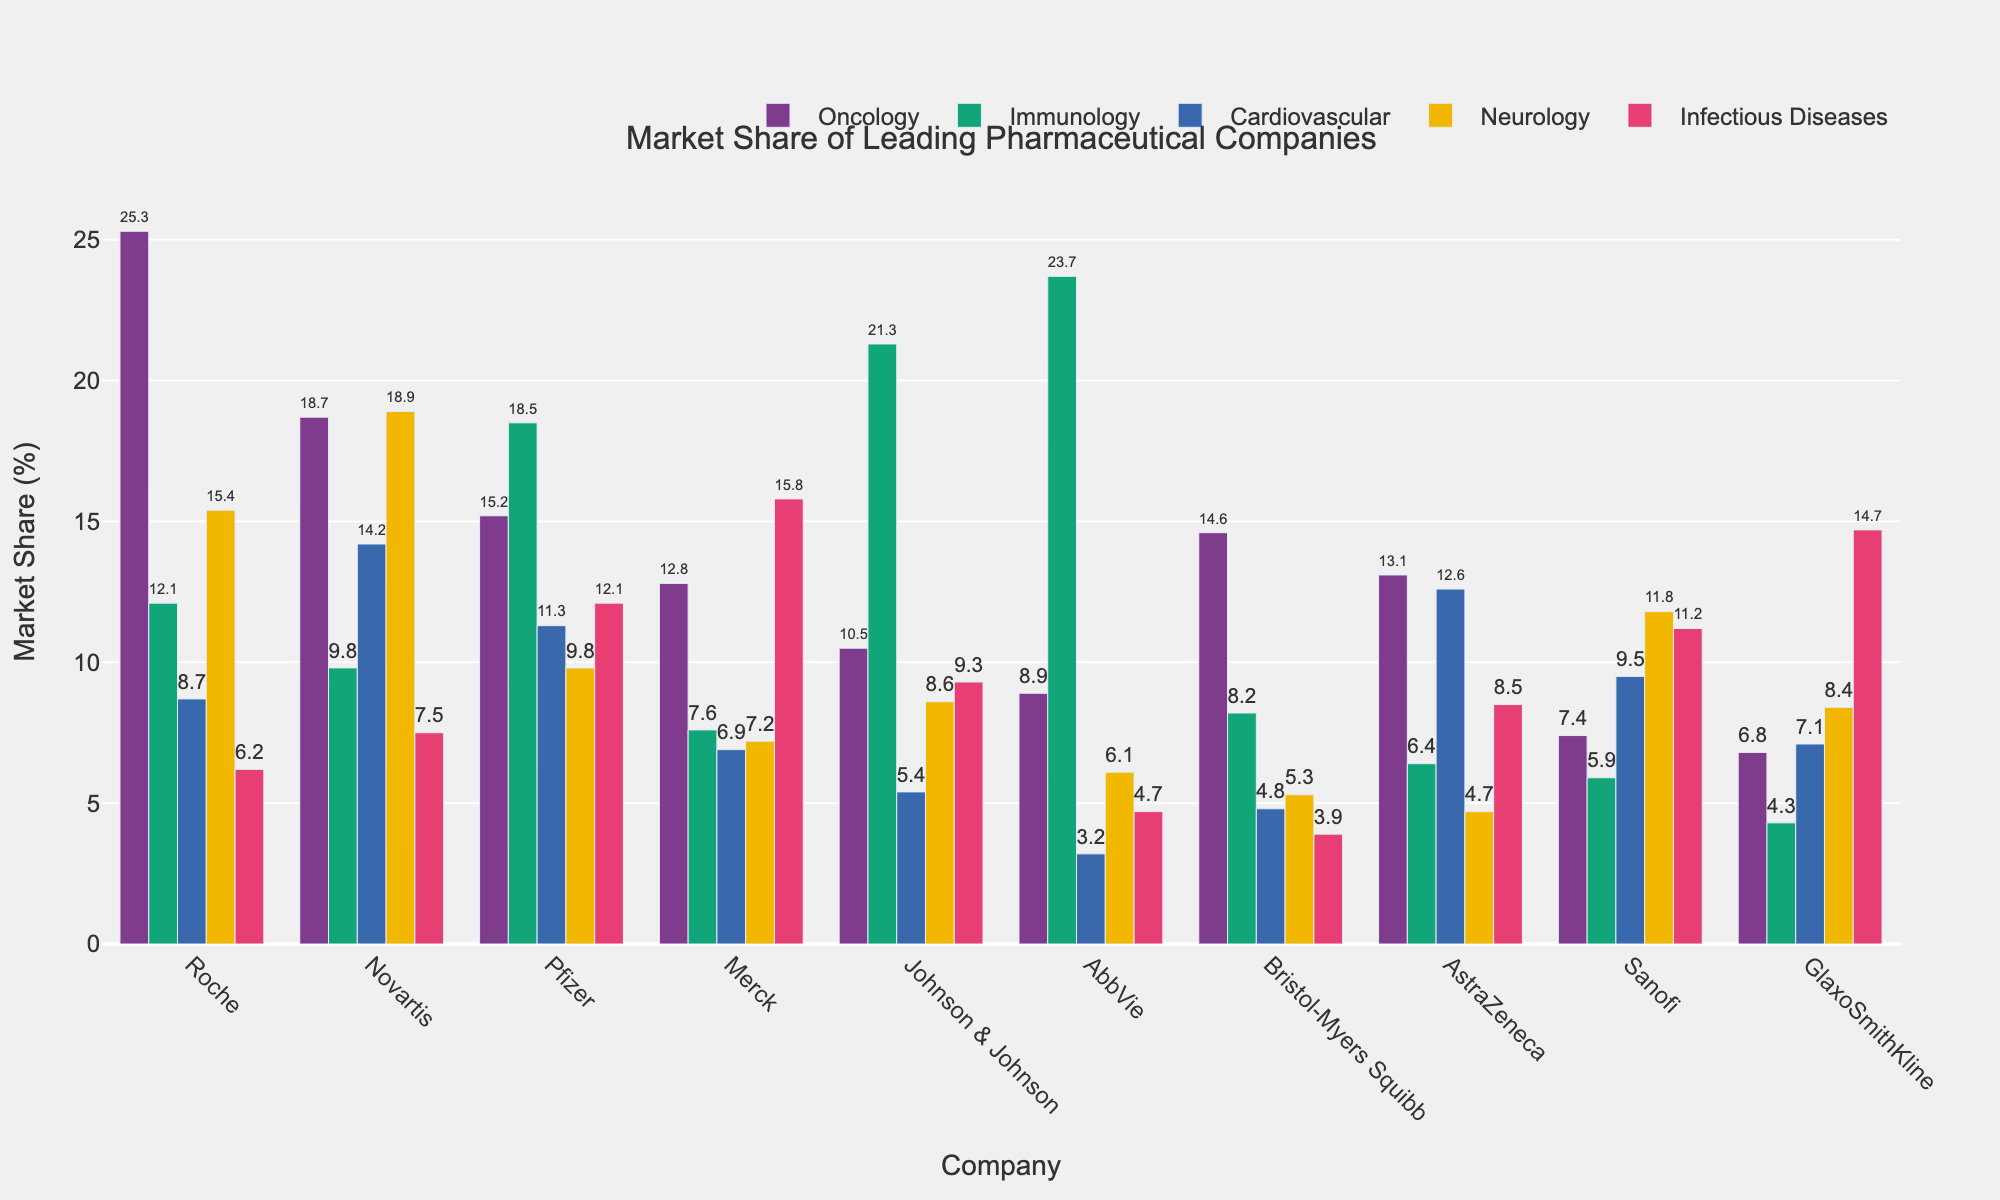What is the company with the highest market share in Immunology? Look at the bar heights for Immunology. The highest bar represents AbbVie, which has the greatest market share in this segment.
Answer: AbbVie Which company has the lowest market share in Oncology? Observe the heights of the bars for Oncology. The shortest bar indicates Sanofi has the lowest market share in this segment.
Answer: Sanofi Which therapeutic segment has the most balanced distribution of market shares among the companies? This involves comparing the differences in bar heights across all therapeutic segments. The Immunology segment shows relatively balanced heights without extreme values across the companies.
Answer: Immunology How does Roche's market share in Infectious Diseases compare to Pfizer's? Compare the bar heights for Roche and Pfizer in the Infectious Diseases segment. Roche's share is lower than Pfizer's, as indicated by the shorter bar.
Answer: Lower What is the total market share of Novartis across all therapeutic segments? Add Novartis’s market share values from all segments: 18.7 (Oncology) + 9.8 (Immunology) + 14.2 (Cardiovascular) + 18.9 (Neurology) + 7.5 (Infectious Diseases). This equals 69.1%.
Answer: 69.1% What is the average market share of Johnson & Johnson across all segments? Calculate the average by summing Johnson & Johnson’s values in all segments: 10.5 (Oncology) + 21.3 (Immunology) + 5.4 (Cardiovascular) + 8.6 (Neurology) + 9.3 (Infectious Diseases) = 55.1. Then 55.1 / 5 segments = 11.02%.
Answer: 11.02% Which company dominates in the Neurology segment? Look at the highest bar in the Neurology segment. The tallest bar belongs to Novartis, indicating it has the highest market share in Neurology.
Answer: Novartis What is the combined market share of Johnson & Johnson and Pfizer in the Immunology segment? Add Johnson & Johnson's and Pfizer's market shares in Immunology: 21.3 + 18.5 = 39.8%.
Answer: 39.8% Who has a higher market share in Cardiovascular: AstraZeneca or Bristol-Myers Squibb? Compare the bar heights for AstraZeneca and Bristol-Myers Squibb in Cardiovascular. The higher bar height indicates AstraZeneca has a higher market share.
Answer: AstraZeneca What is the difference in market share between the leading and the second-leading company in Oncology? Identify the top two companies in Oncology (Roche with 25.3 and Novartis with 18.7), then subtract Novartis's market share from Roche's: 25.3 - 18.7 = 6.6%.
Answer: 6.6% 